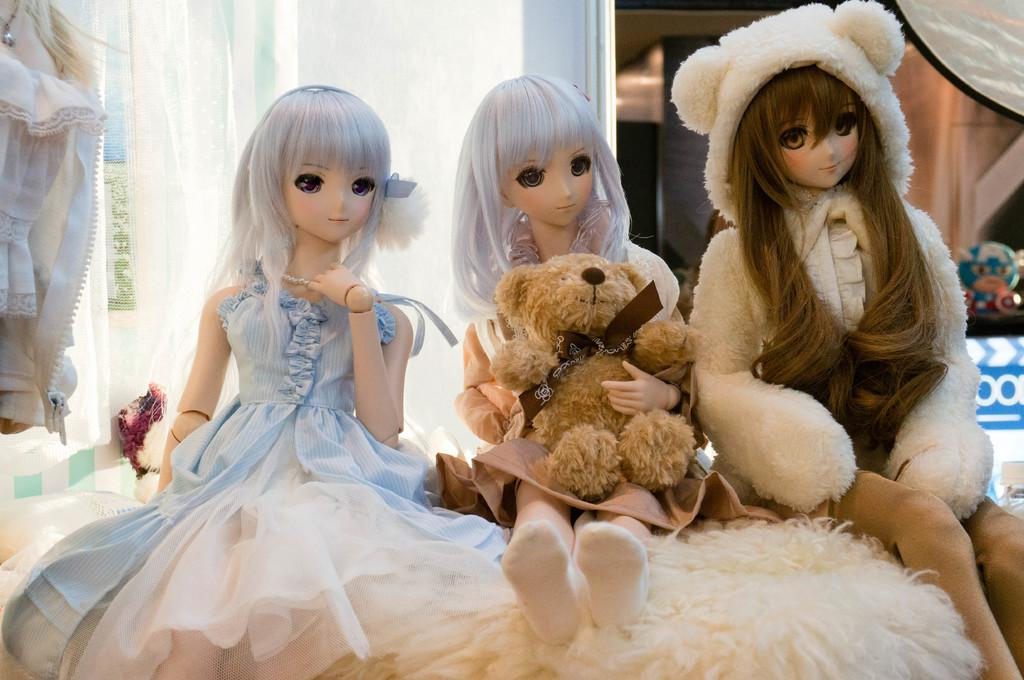What type of objects are in the image? There are dolls in the image. Can you describe the background of the image? The background of the image is blurred. What else can be seen in the background of the image? There is a toy visible in the background of the image. What type of copy is being made on the sidewalk in the image? There is no sidewalk or copying activity present in the image. Is there any snow visible in the image? There is no snow present in the image. 